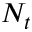<formula> <loc_0><loc_0><loc_500><loc_500>N _ { t }</formula> 